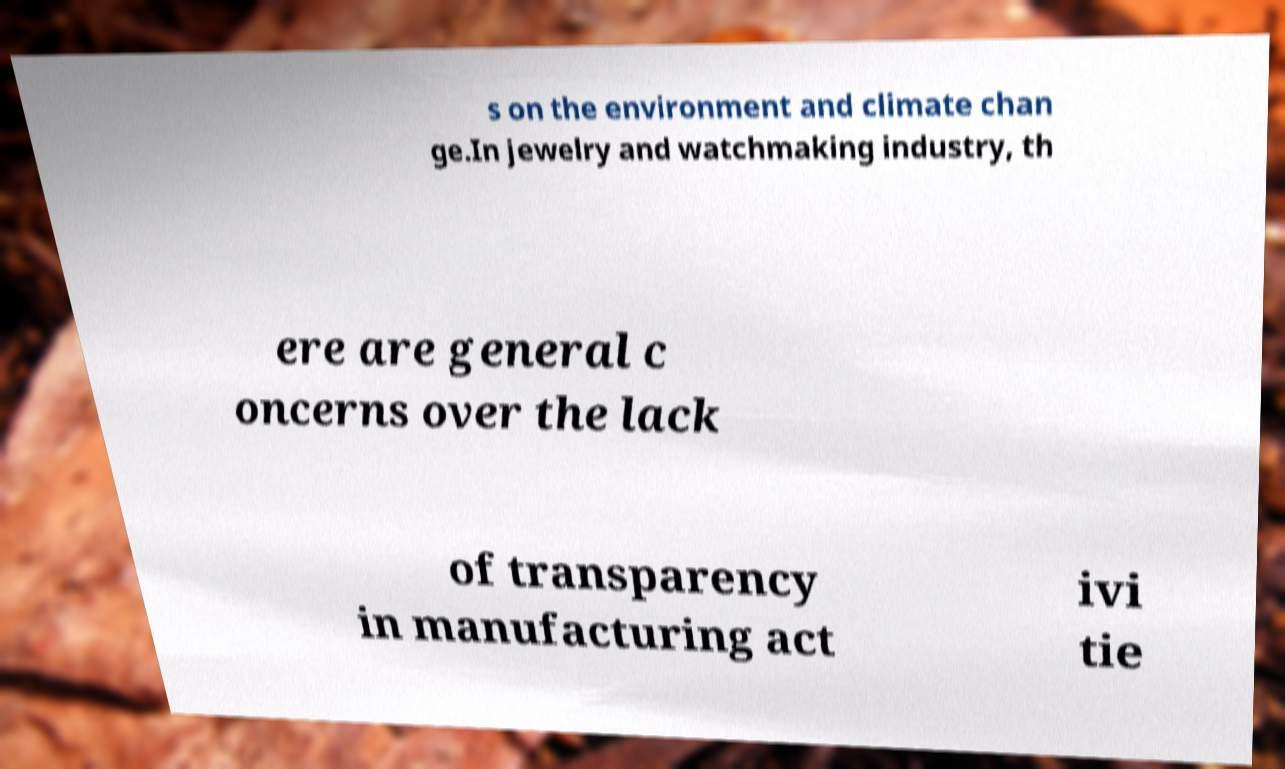Could you assist in decoding the text presented in this image and type it out clearly? s on the environment and climate chan ge.In jewelry and watchmaking industry, th ere are general c oncerns over the lack of transparency in manufacturing act ivi tie 